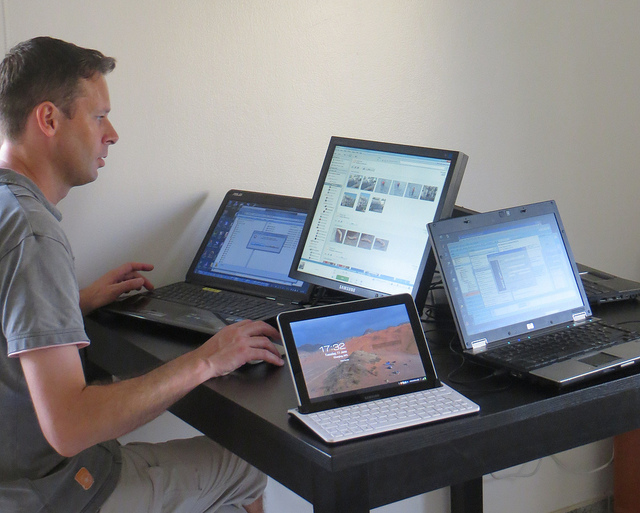Please transcribe the text in this image. 22 